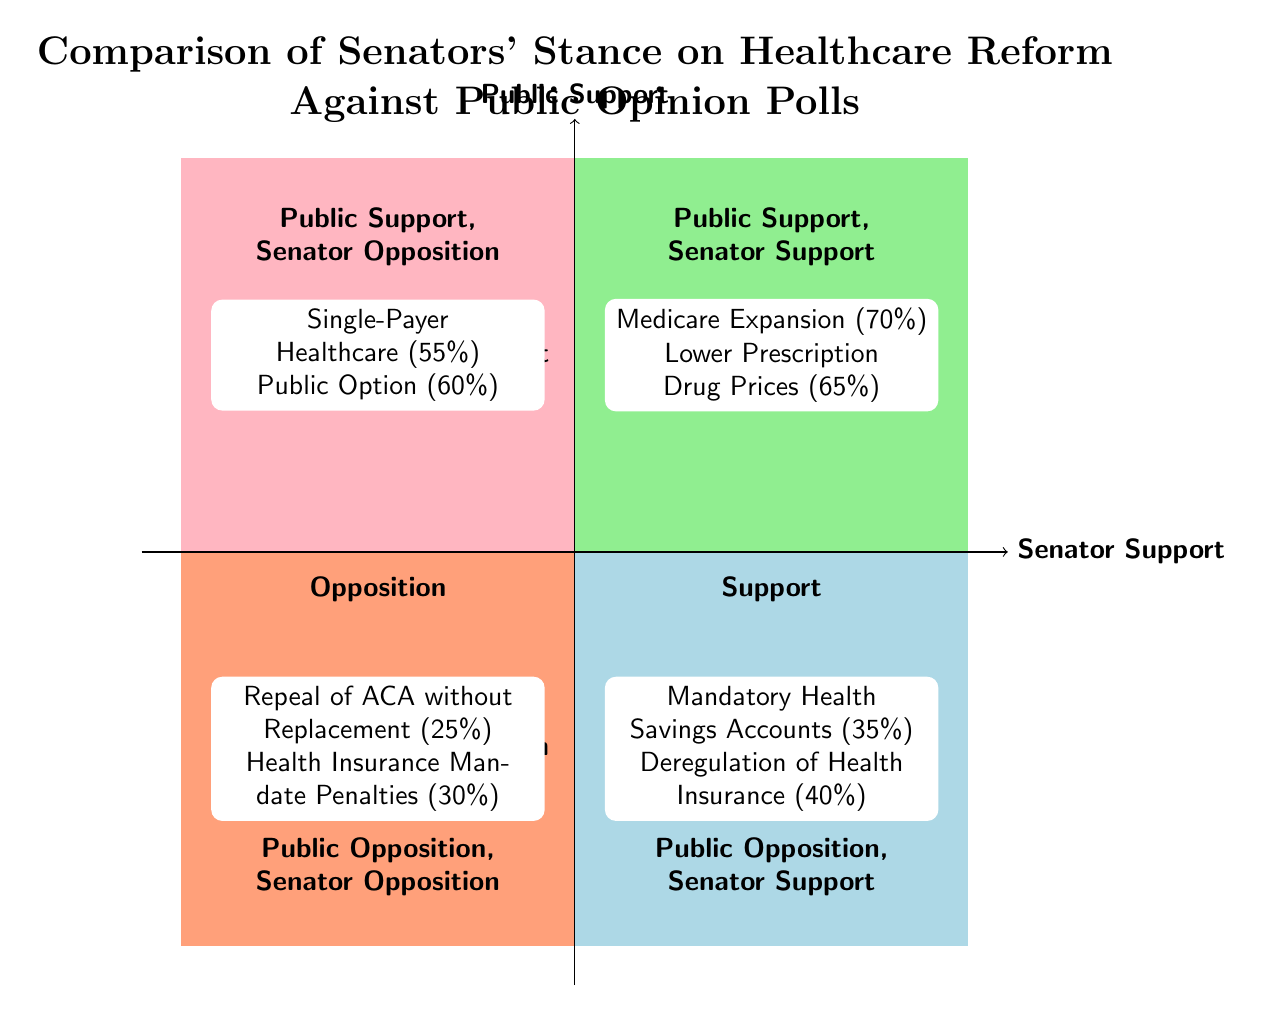What policy has the highest public support and senator support? The quadrant labeled "Public Support, Senator Support" contains the policies "Medicare Expansion" and "Lower Prescription Drug Prices". Among these, "Medicare Expansion" has the highest public support at 70%.
Answer: Medicare Expansion Which senators oppose the "Public Option" policy? The "Public Option" policy is located in the "Public Support, Senator Opposition" quadrant, and it states that Ted Cruz and Ron Johnson oppose this policy.
Answer: Ted Cruz, Ron Johnson What is the public support percentage for "Mandatory Health Savings Accounts"? This policy is found in the "Public Opposition, Senator Support" quadrant, indicating that it has a public support of 35%.
Answer: 35% Which quadrant contains policies that both the public and senators oppose? The quadrant that contains policies that both the public and senators oppose is labeled "Public Opposition, Senator Opposition".
Answer: Public Opposition, Senator Opposition How many senators support "Lower Prescription Drug Prices"? The policy "Lower Prescription Drug Prices" is in the quadrant "Public Support, Senator Support", and it lists the senators Amy Klobuchar and Chuck Schumer, indicating there are two senators supporting this policy.
Answer: 2 How does public support for "Single-Payer Healthcare" compare to that for "Repeal of ACA without Replacement"? The "Single-Payer Healthcare" policy has public support of 55% in the "Public Support, Senator Opposition" quadrant, while the "Repeal of ACA without Replacement" has public support of 25% in the "Public Opposition, Senator Opposition" quadrant. Therefore, 55% is higher than 25%.
Answer: 55% higher than 25% Which quadrant contains policies that the public supports but senators oppose? This information pertains to the "Public Support, Senator Opposition" quadrant, which includes policies like "Single-Payer Healthcare" and "Public Option".
Answer: Public Support, Senator Opposition What is the public support percentage for "Health Insurance Mandate Penalties"? This policy is located in the "Public Opposition, Senator Opposition" quadrant and has a public support of 30%.
Answer: 30% 